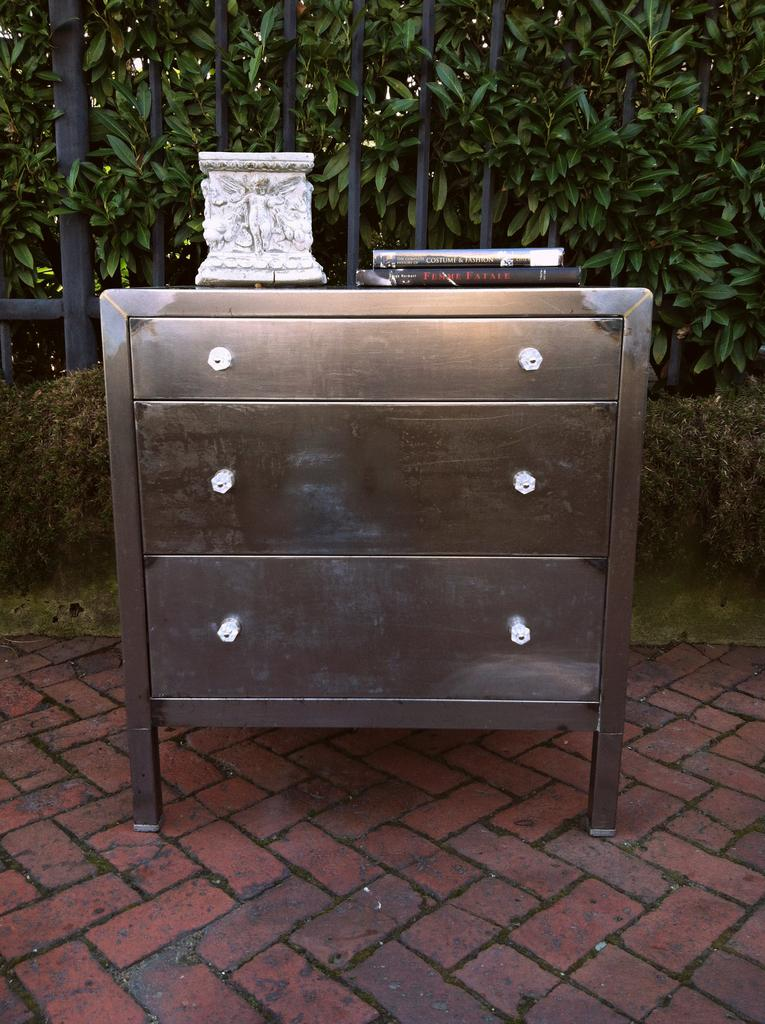What is located in the center of the image? There is a table in the center of the image. What feature is associated with the table? There are drawers associated with the table. What is placed on top of the table? There is a sculpture and books on the table. What can be seen in the background of the image? There is a wall, a fence, and plants in the background of the image. How many people are swimming in the image? There are no people swimming in the image. What color is the tongue of the person in the image? There is no person or tongue present in the image. 